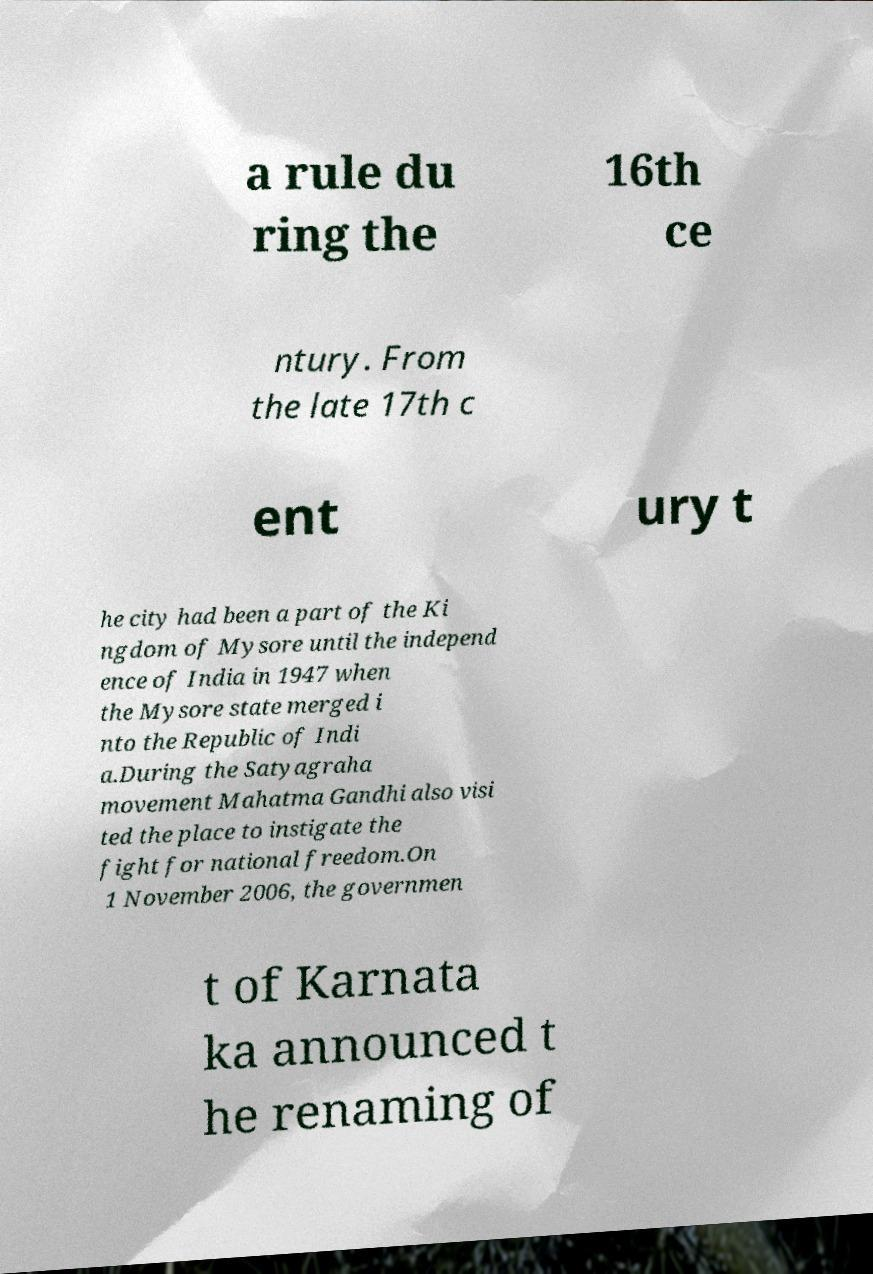Could you extract and type out the text from this image? a rule du ring the 16th ce ntury. From the late 17th c ent ury t he city had been a part of the Ki ngdom of Mysore until the independ ence of India in 1947 when the Mysore state merged i nto the Republic of Indi a.During the Satyagraha movement Mahatma Gandhi also visi ted the place to instigate the fight for national freedom.On 1 November 2006, the governmen t of Karnata ka announced t he renaming of 